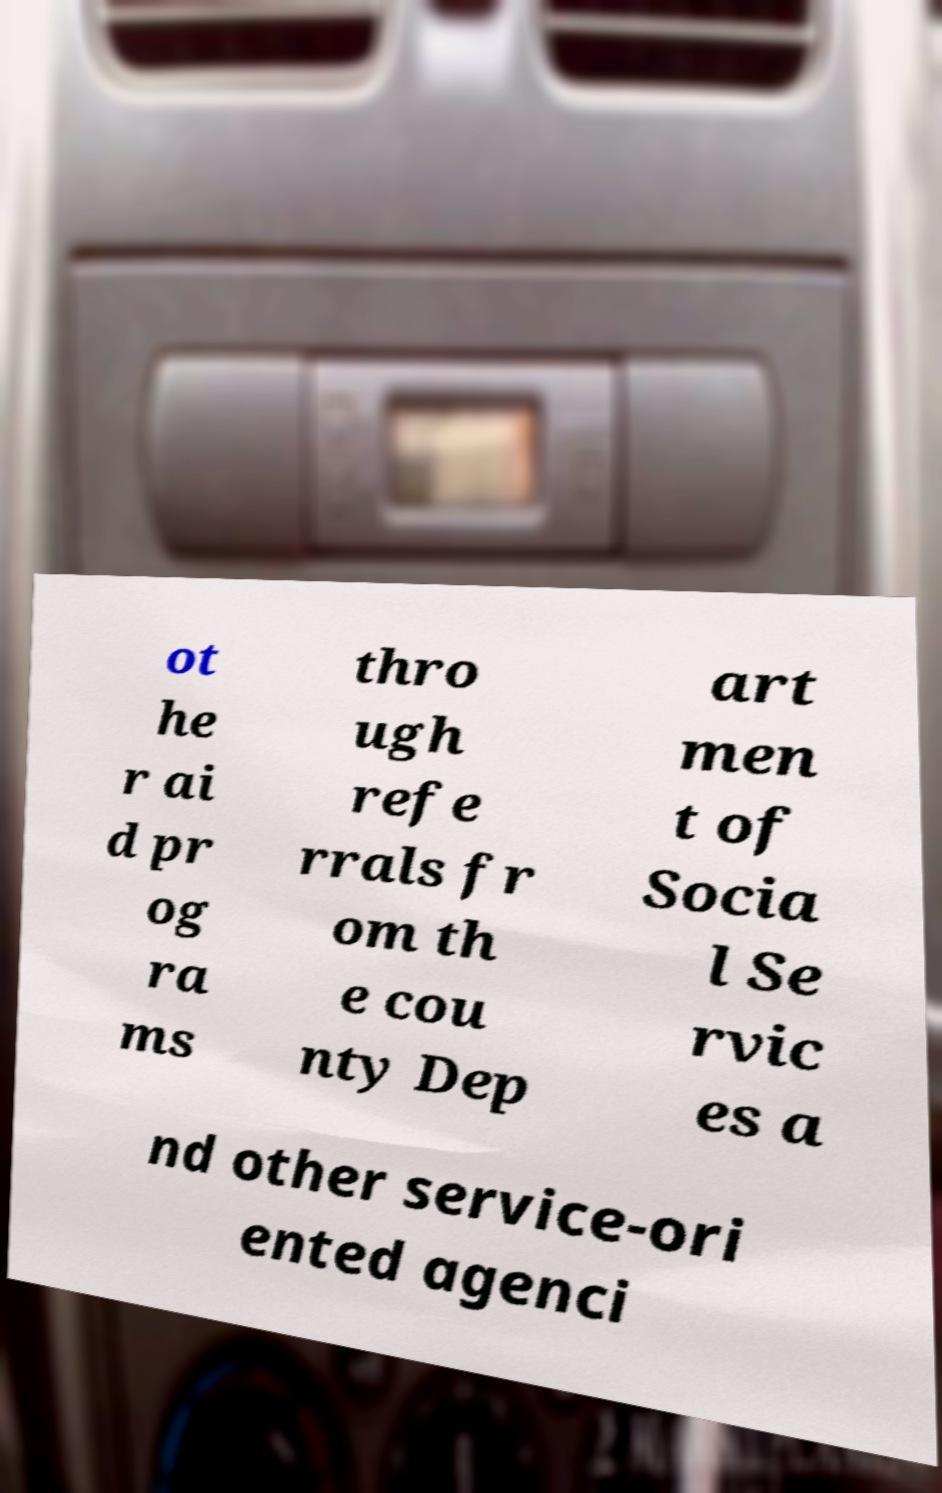Can you read and provide the text displayed in the image?This photo seems to have some interesting text. Can you extract and type it out for me? ot he r ai d pr og ra ms thro ugh refe rrals fr om th e cou nty Dep art men t of Socia l Se rvic es a nd other service-ori ented agenci 